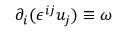<formula> <loc_0><loc_0><loc_500><loc_500>\partial _ { i } ( \epsilon ^ { i j } u _ { j } ) \equiv \omega</formula> 